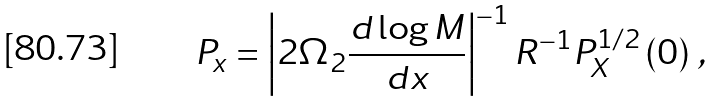<formula> <loc_0><loc_0><loc_500><loc_500>P _ { x } = \left | 2 \Omega _ { 2 } \frac { d \log M } { d x } \right | ^ { - 1 } R ^ { - 1 } P _ { X } ^ { 1 / 2 } \left ( 0 \right ) \, ,</formula> 